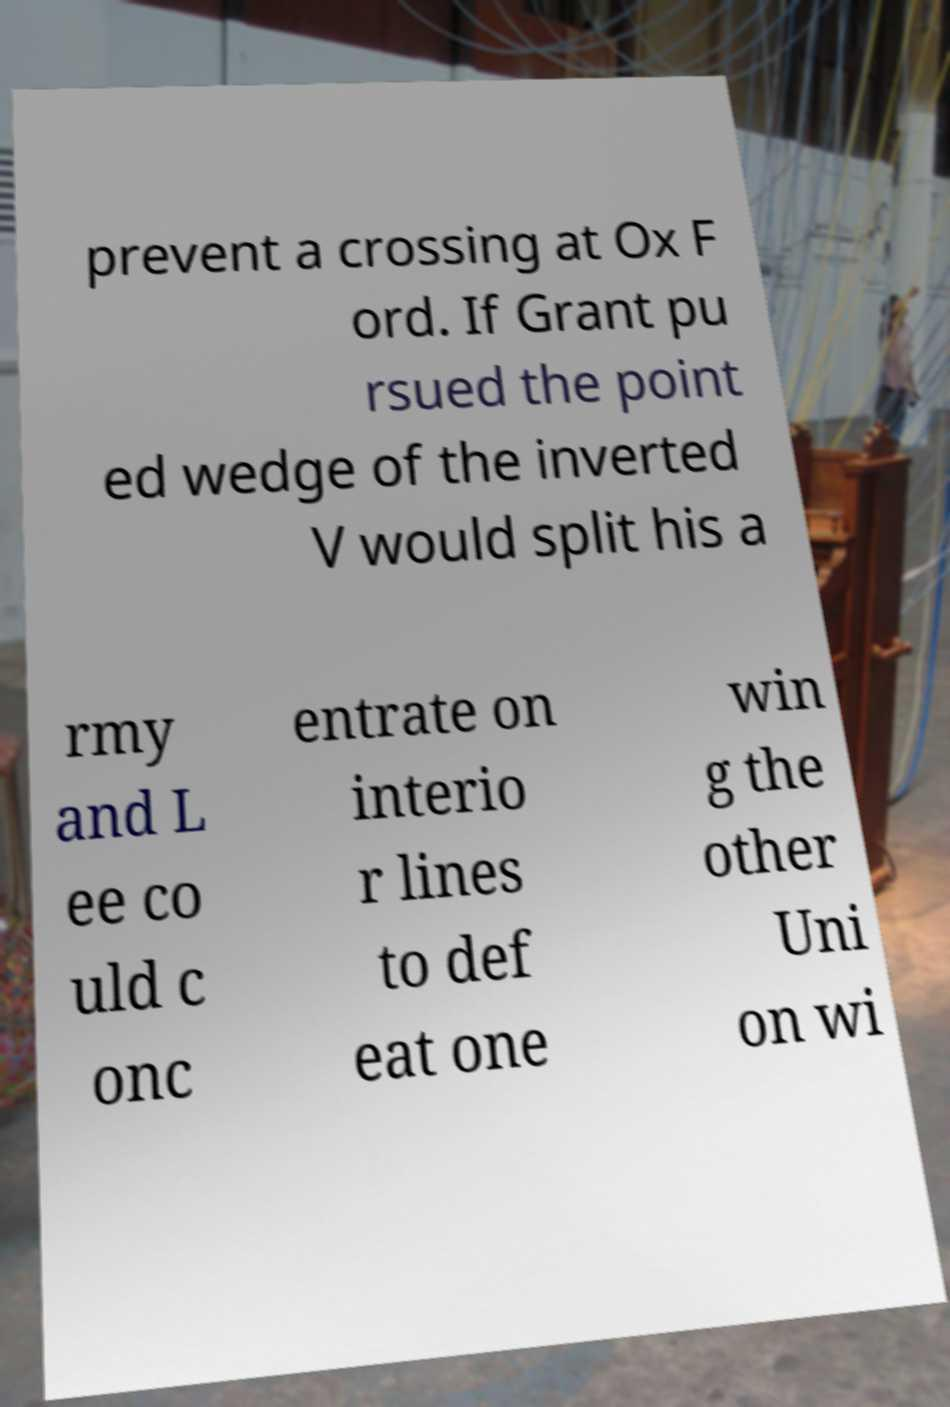Could you extract and type out the text from this image? prevent a crossing at Ox F ord. If Grant pu rsued the point ed wedge of the inverted V would split his a rmy and L ee co uld c onc entrate on interio r lines to def eat one win g the other Uni on wi 